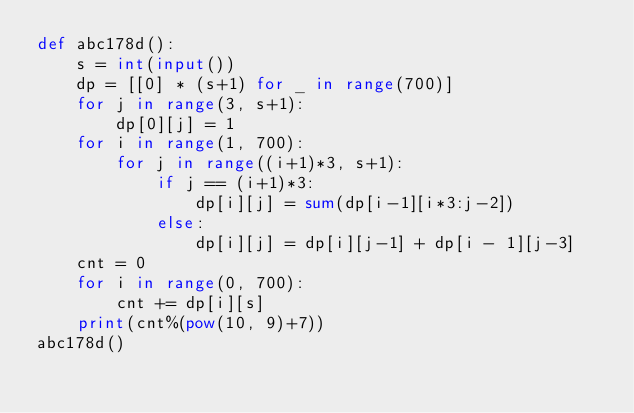<code> <loc_0><loc_0><loc_500><loc_500><_Python_>def abc178d():
    s = int(input())
    dp = [[0] * (s+1) for _ in range(700)]
    for j in range(3, s+1):
        dp[0][j] = 1
    for i in range(1, 700):
        for j in range((i+1)*3, s+1):
            if j == (i+1)*3:
                dp[i][j] = sum(dp[i-1][i*3:j-2])
            else:
                dp[i][j] = dp[i][j-1] + dp[i - 1][j-3]
    cnt = 0
    for i in range(0, 700):
        cnt += dp[i][s]
    print(cnt%(pow(10, 9)+7))
abc178d()</code> 